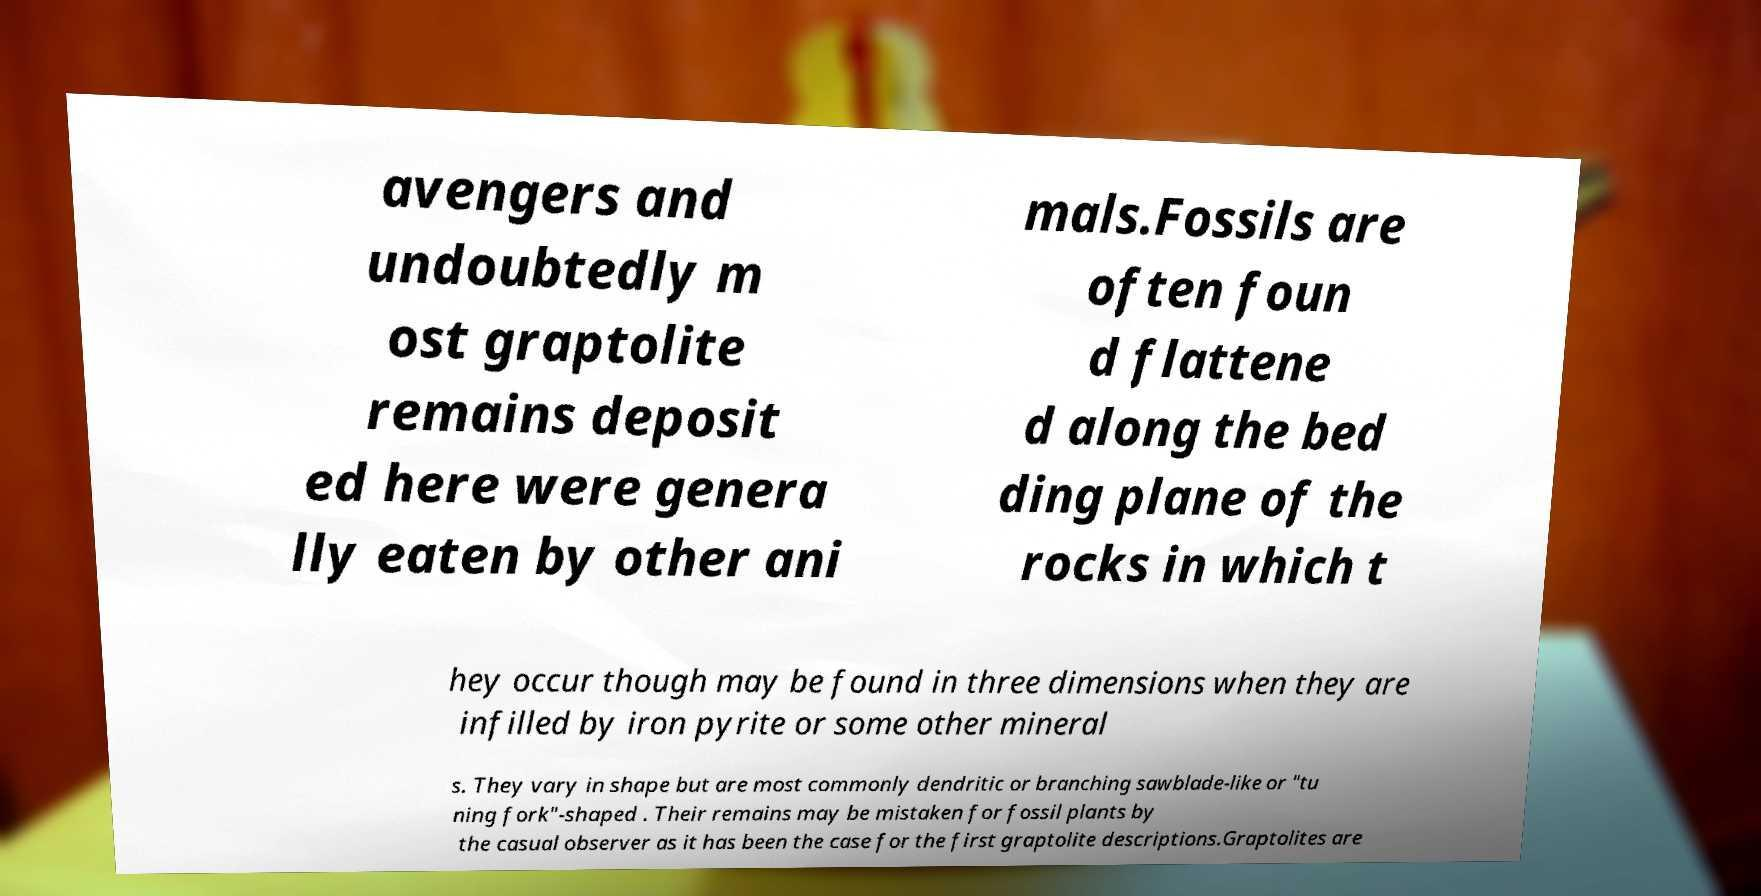Can you read and provide the text displayed in the image?This photo seems to have some interesting text. Can you extract and type it out for me? avengers and undoubtedly m ost graptolite remains deposit ed here were genera lly eaten by other ani mals.Fossils are often foun d flattene d along the bed ding plane of the rocks in which t hey occur though may be found in three dimensions when they are infilled by iron pyrite or some other mineral s. They vary in shape but are most commonly dendritic or branching sawblade-like or "tu ning fork"-shaped . Their remains may be mistaken for fossil plants by the casual observer as it has been the case for the first graptolite descriptions.Graptolites are 